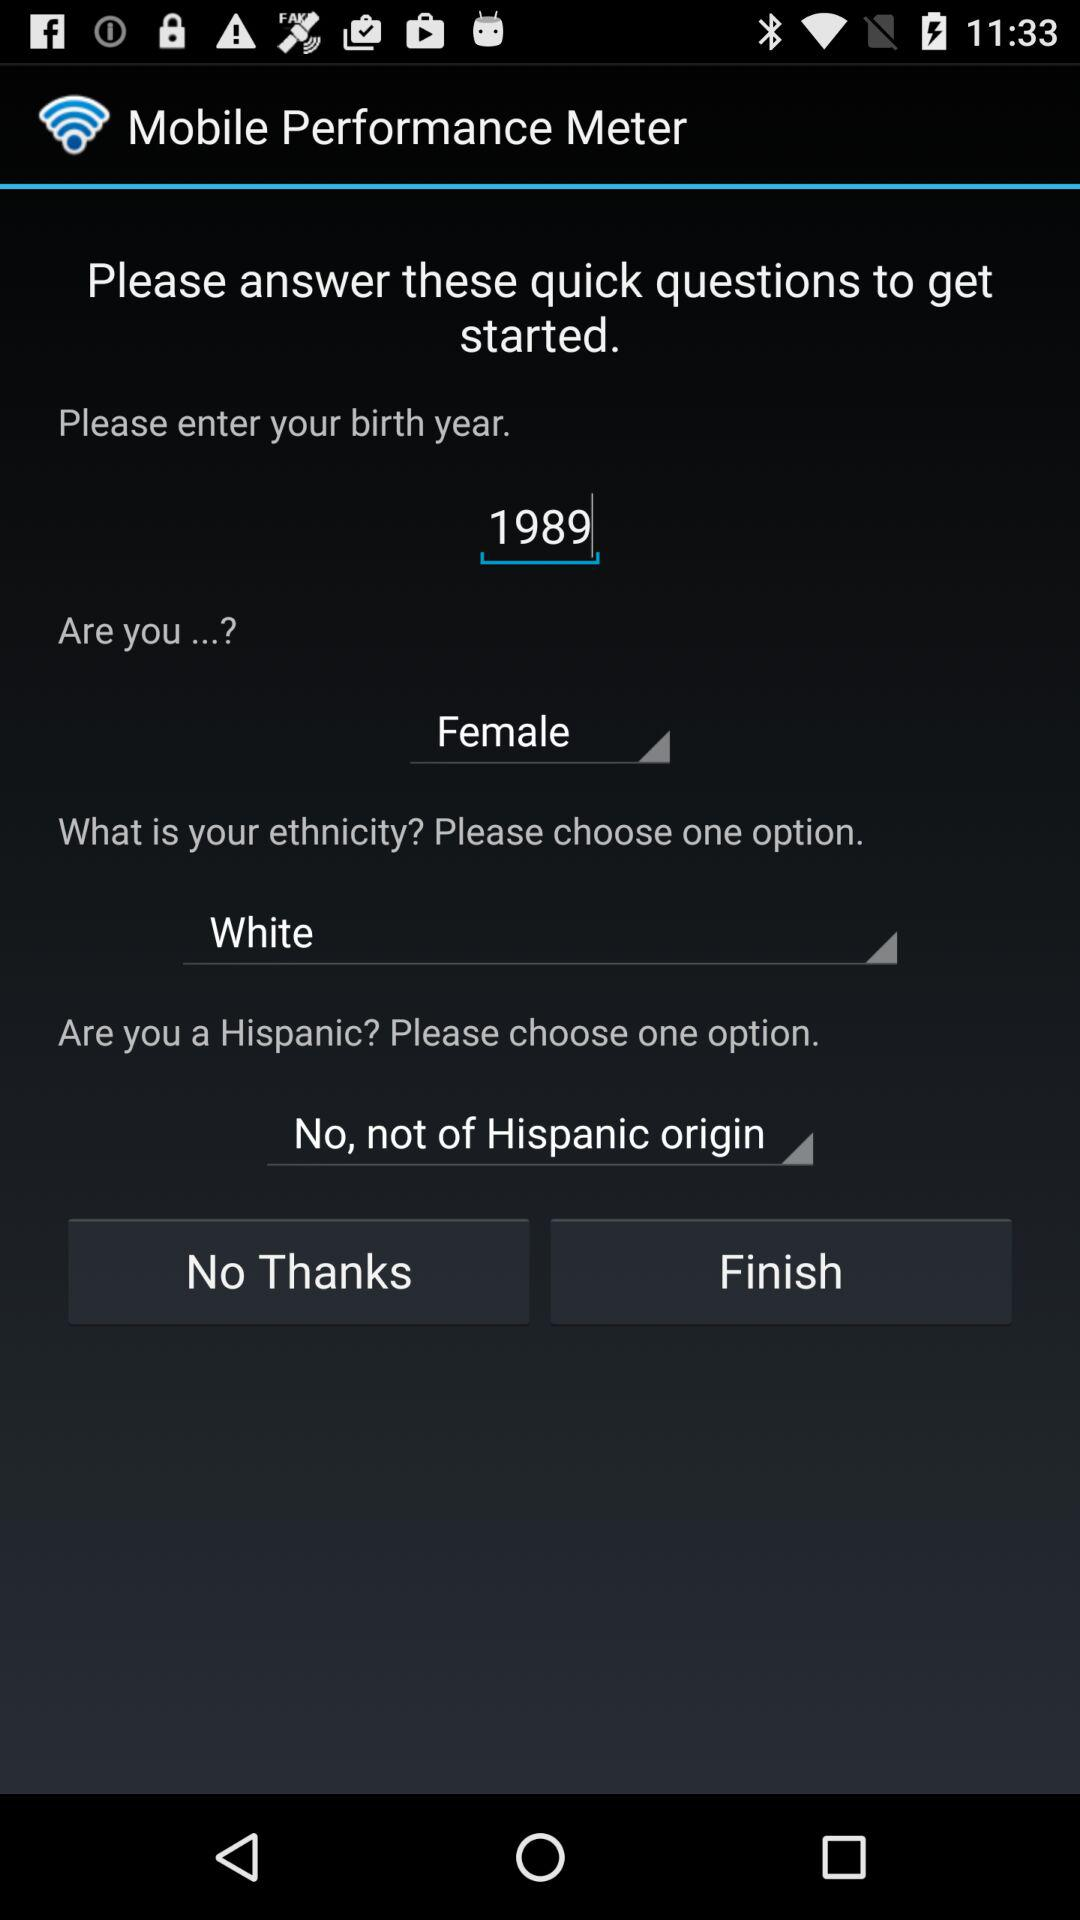What is the selected gender? The selected gender is female. 